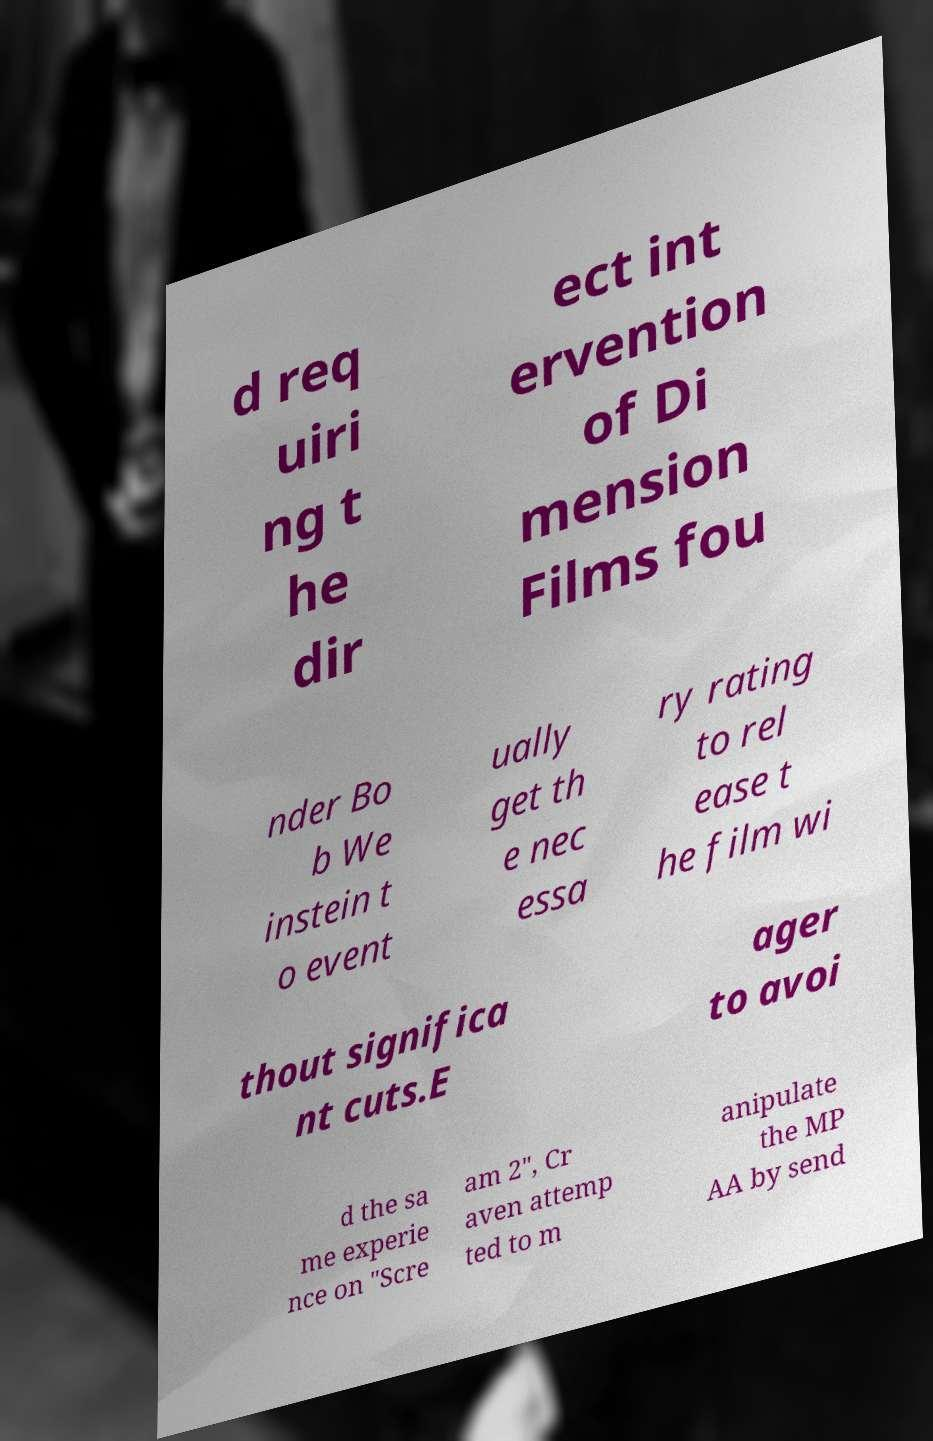What messages or text are displayed in this image? I need them in a readable, typed format. d req uiri ng t he dir ect int ervention of Di mension Films fou nder Bo b We instein t o event ually get th e nec essa ry rating to rel ease t he film wi thout significa nt cuts.E ager to avoi d the sa me experie nce on "Scre am 2", Cr aven attemp ted to m anipulate the MP AA by send 